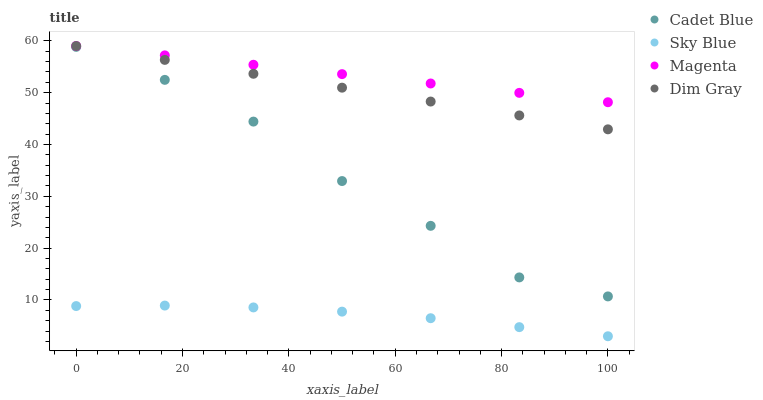Does Sky Blue have the minimum area under the curve?
Answer yes or no. Yes. Does Magenta have the maximum area under the curve?
Answer yes or no. Yes. Does Cadet Blue have the minimum area under the curve?
Answer yes or no. No. Does Cadet Blue have the maximum area under the curve?
Answer yes or no. No. Is Magenta the smoothest?
Answer yes or no. Yes. Is Cadet Blue the roughest?
Answer yes or no. Yes. Is Cadet Blue the smoothest?
Answer yes or no. No. Is Magenta the roughest?
Answer yes or no. No. Does Sky Blue have the lowest value?
Answer yes or no. Yes. Does Cadet Blue have the lowest value?
Answer yes or no. No. Does Dim Gray have the highest value?
Answer yes or no. Yes. Does Cadet Blue have the highest value?
Answer yes or no. No. Is Cadet Blue less than Magenta?
Answer yes or no. Yes. Is Cadet Blue greater than Sky Blue?
Answer yes or no. Yes. Does Magenta intersect Dim Gray?
Answer yes or no. Yes. Is Magenta less than Dim Gray?
Answer yes or no. No. Is Magenta greater than Dim Gray?
Answer yes or no. No. Does Cadet Blue intersect Magenta?
Answer yes or no. No. 